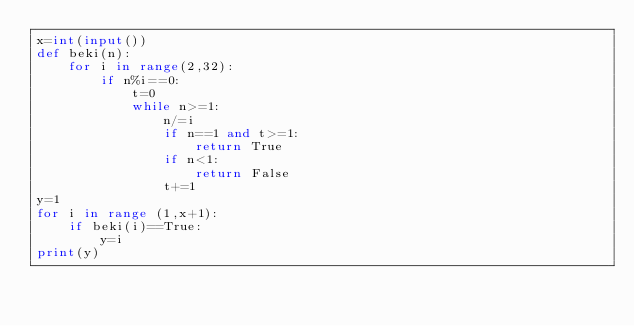Convert code to text. <code><loc_0><loc_0><loc_500><loc_500><_Python_>x=int(input())
def beki(n):
    for i in range(2,32):
        if n%i==0:
            t=0
            while n>=1:
                n/=i
                if n==1 and t>=1:
                    return True
                if n<1:
                    return False
                t+=1
y=1
for i in range (1,x+1):
    if beki(i)==True:
        y=i
print(y)
</code> 